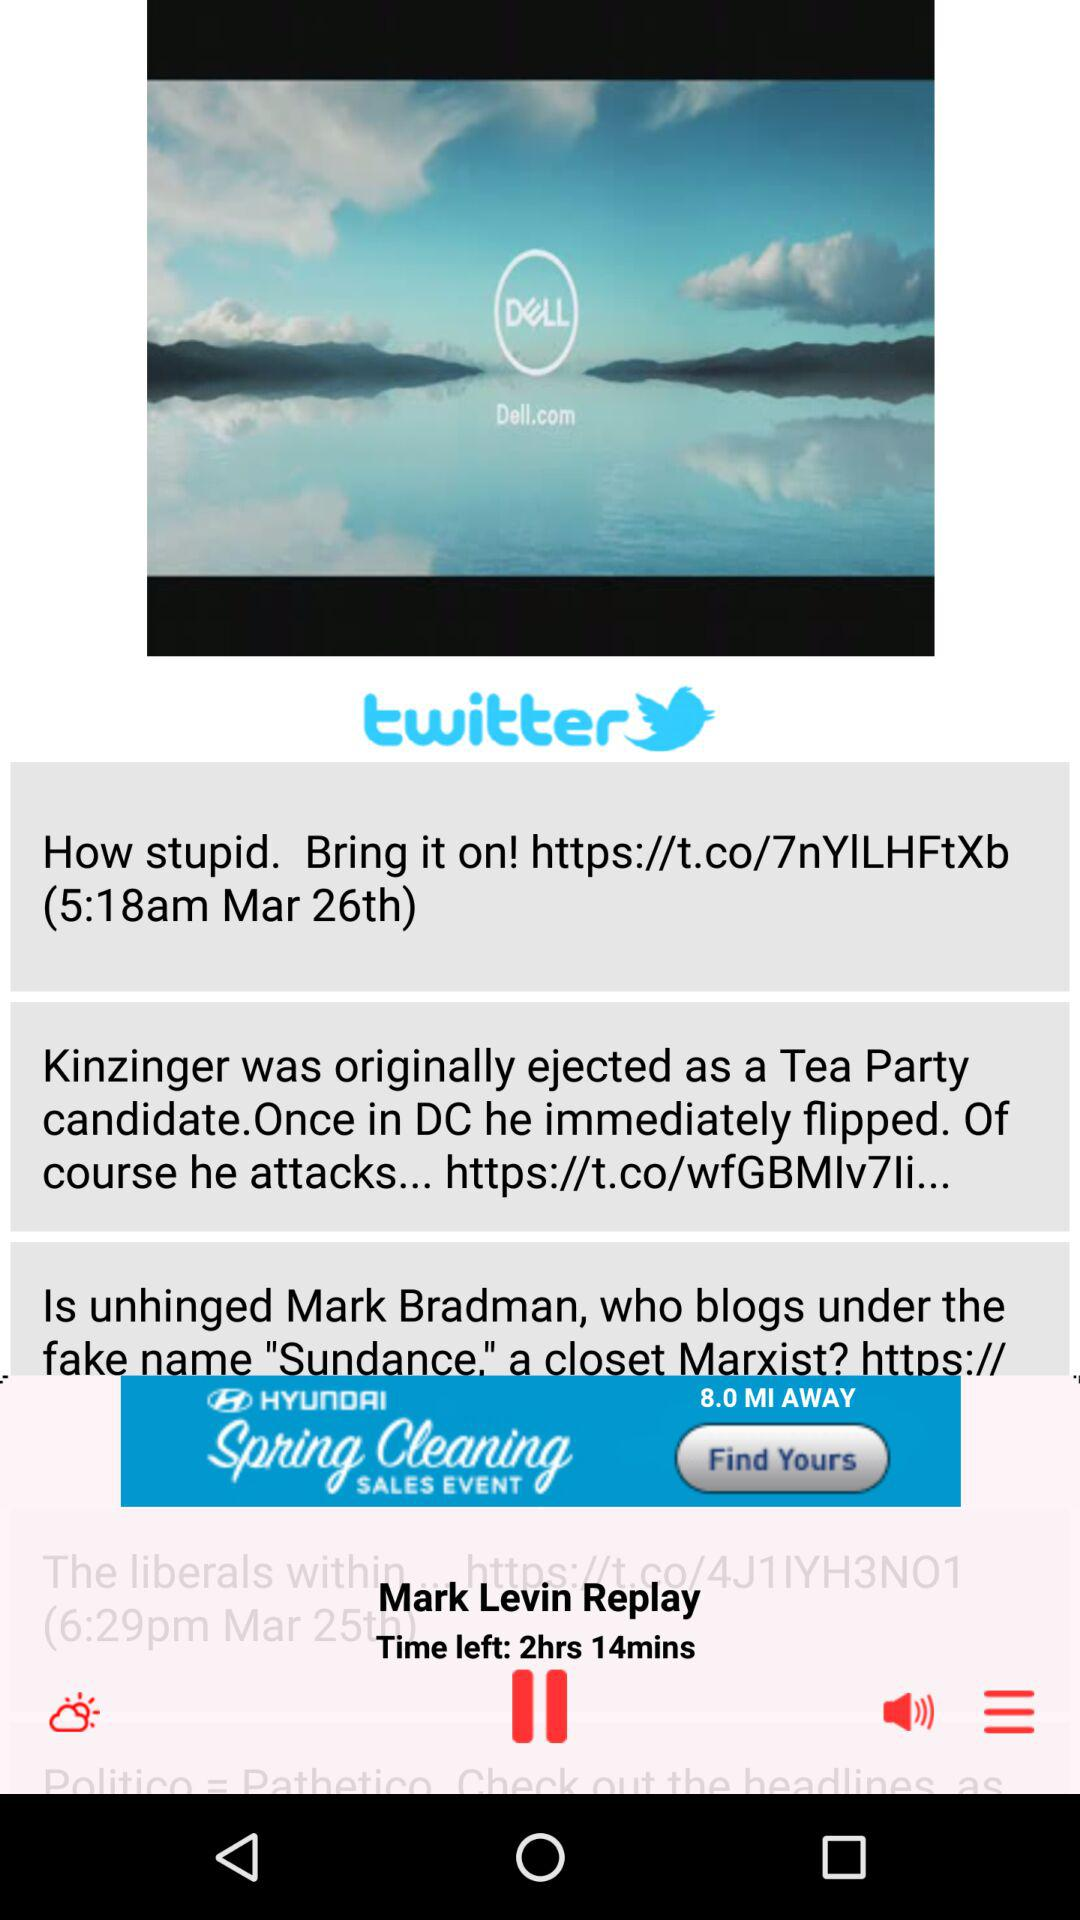How high is the volume?
When the provided information is insufficient, respond with <no answer>. <no answer> 